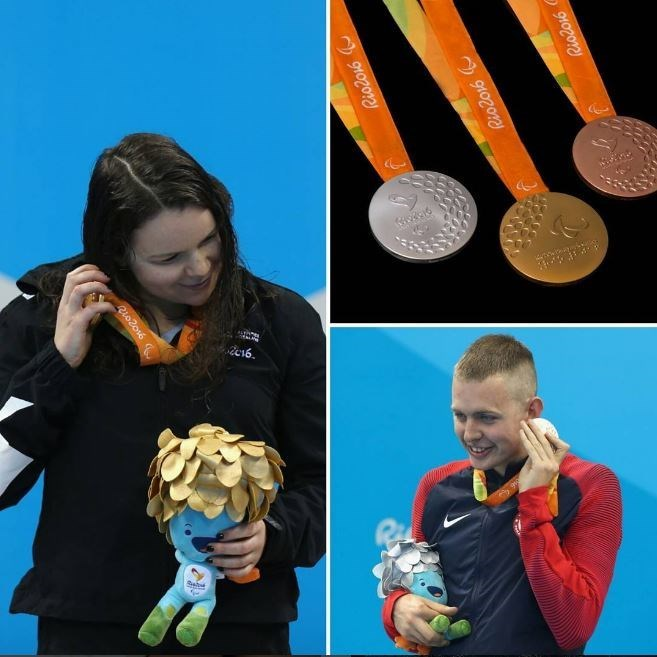What might the athletes be thinking about as they hold their medals? As they hold their medals, the athletes might be reflecting on the countless hours of training that led to this moment, the support from their coaches and families, and the obstacles they overcame to achieve this success. They might also be thinking about the significance of representing their country on such a prestigious platform, feeling a profound sense of national pride and personal accomplishment. It's a culmination of their hard work and dedication paying off in the most tangible way possible. 